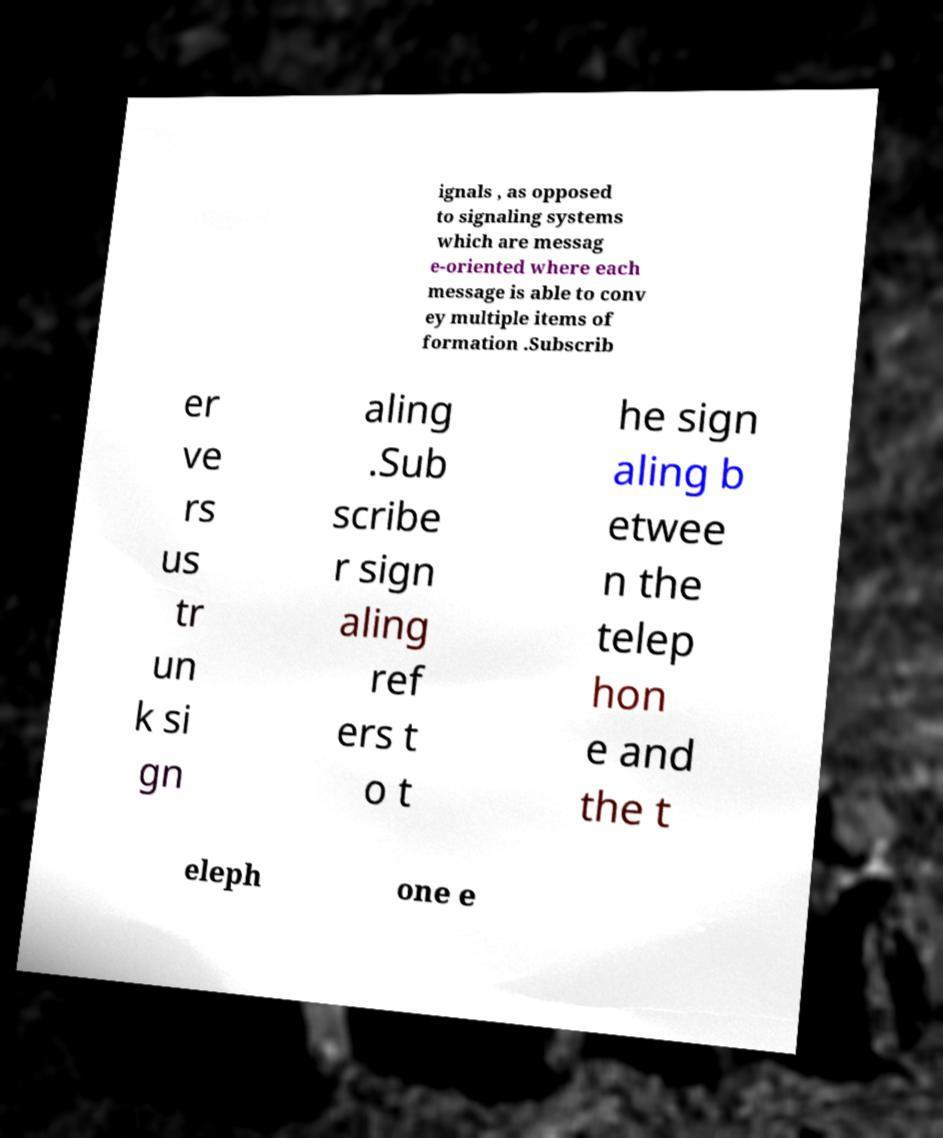Could you assist in decoding the text presented in this image and type it out clearly? ignals , as opposed to signaling systems which are messag e-oriented where each message is able to conv ey multiple items of formation .Subscrib er ve rs us tr un k si gn aling .Sub scribe r sign aling ref ers t o t he sign aling b etwee n the telep hon e and the t eleph one e 